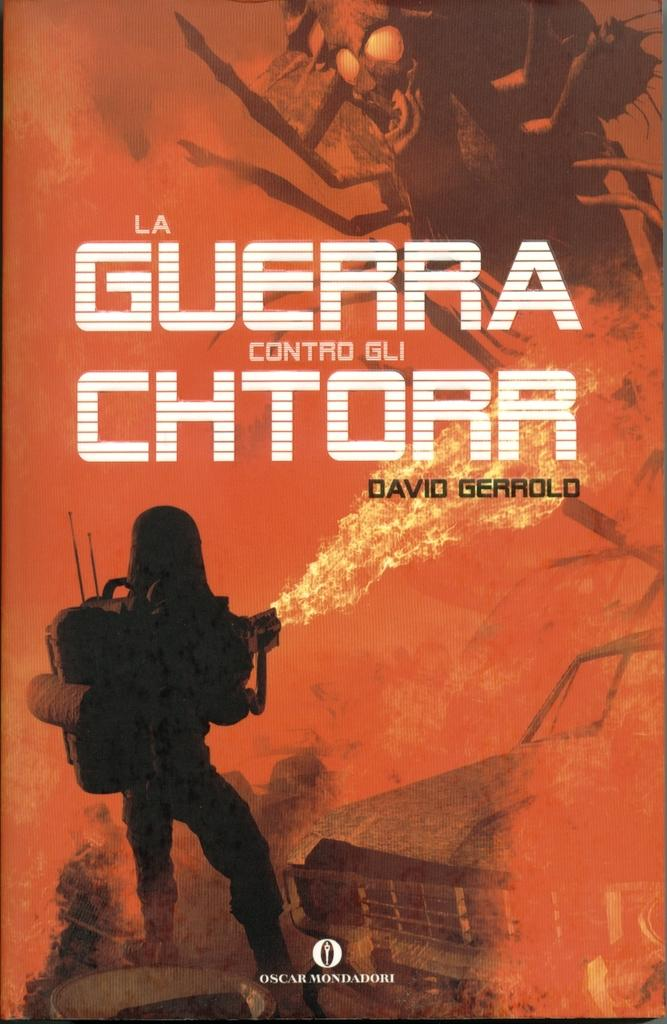<image>
Describe the image concisely. A man shoots a flamethrower in a burnt out hellscape on the cover of a David Gerrold book. 